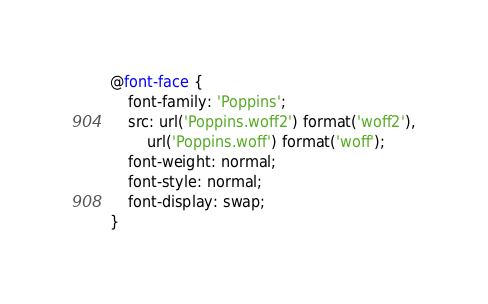Convert code to text. <code><loc_0><loc_0><loc_500><loc_500><_CSS_>@font-face {
    font-family: 'Poppins';
    src: url('Poppins.woff2') format('woff2'),
        url('Poppins.woff') format('woff');
    font-weight: normal;
    font-style: normal;
    font-display: swap;
}

</code> 